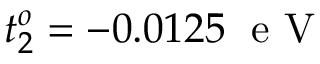<formula> <loc_0><loc_0><loc_500><loc_500>t _ { 2 } ^ { o } = - 0 . 0 1 2 5 \, e V</formula> 